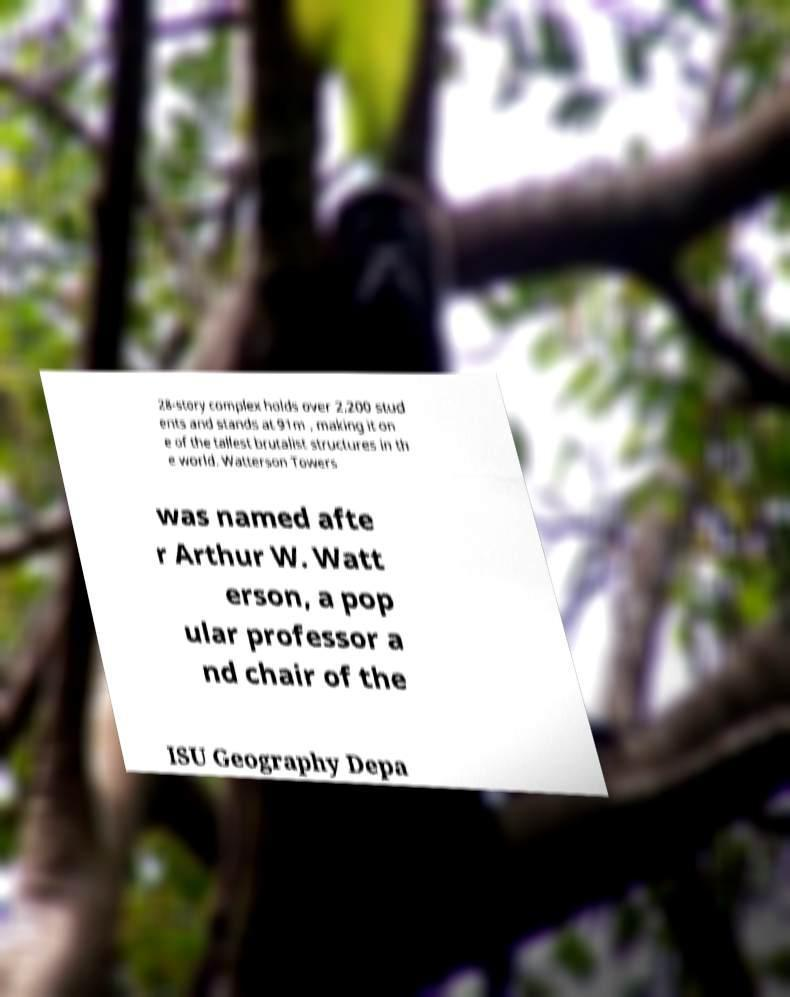I need the written content from this picture converted into text. Can you do that? 28-story complex holds over 2,200 stud ents and stands at 91m , making it on e of the tallest brutalist structures in th e world. Watterson Towers was named afte r Arthur W. Watt erson, a pop ular professor a nd chair of the ISU Geography Depa 